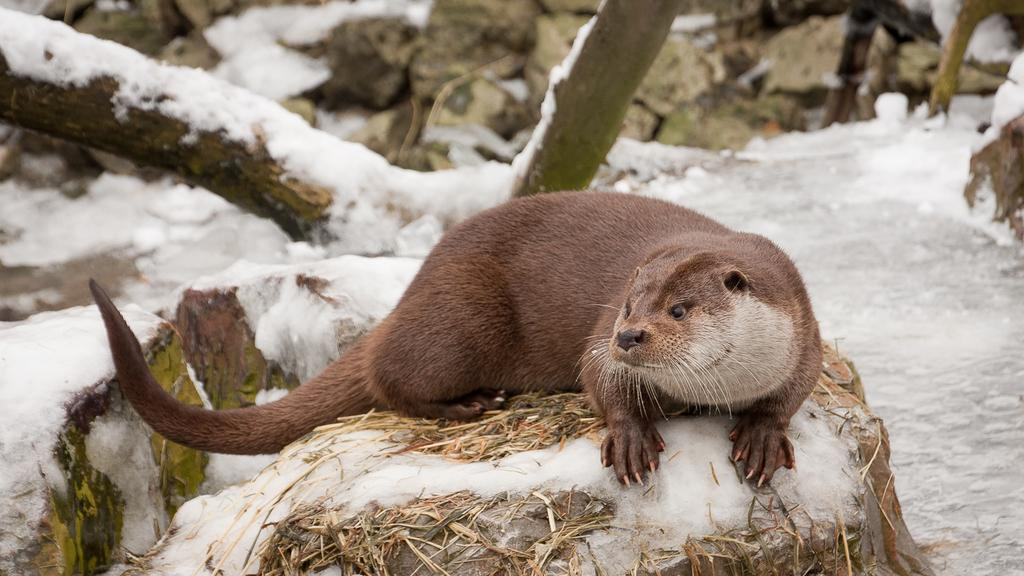What type of animal can be seen in the image? There is an animal in the image, but its specific type cannot be determined from the provided facts. Where is the animal located in the image? The animal is on a stone in the image. What other objects can be seen in the image? There are stones visible in the image. What is the condition of the trees in the image? Trees covered with snow are present in the image. What is the animal's digestion process like in the image? There is no information about the animal's digestion process in the image. Can you tell me how many toads are present in the image? There is no mention of toads in the image; only an unspecified animal is mentioned. 